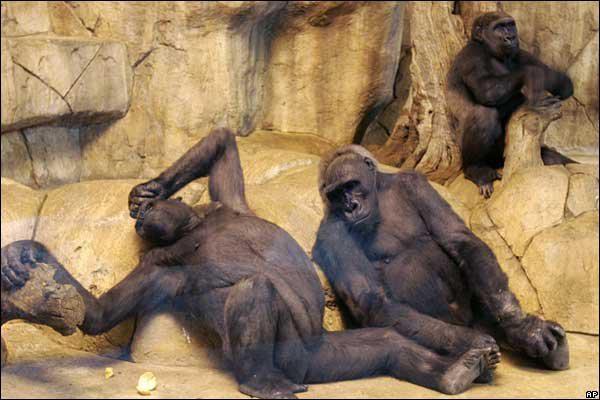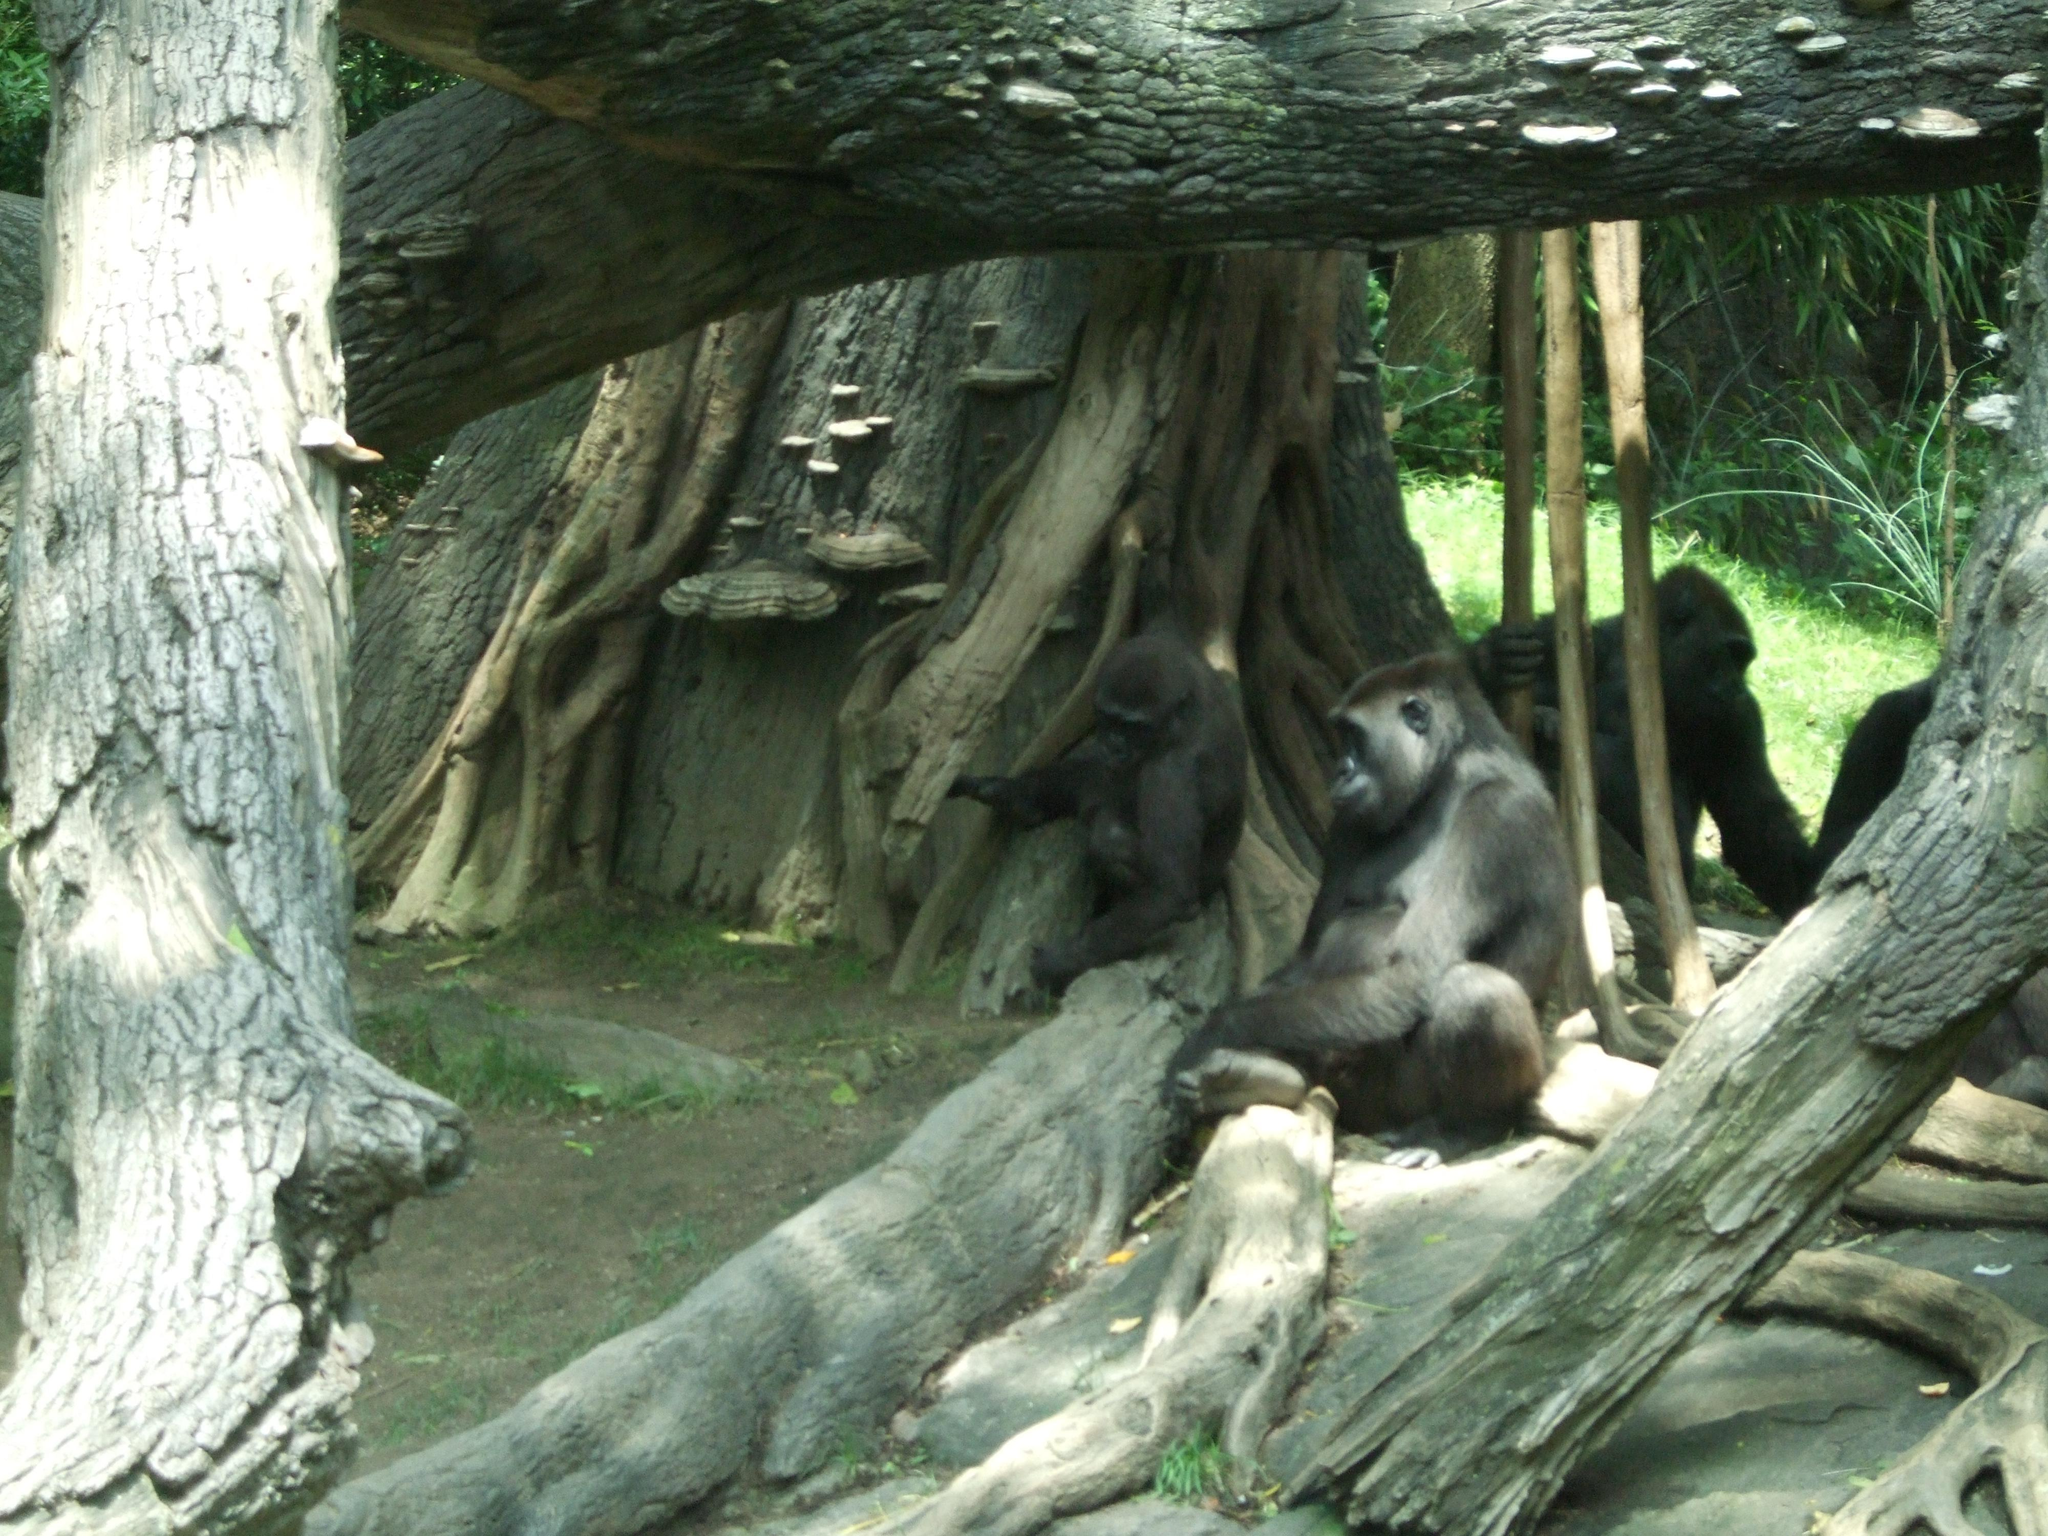The first image is the image on the left, the second image is the image on the right. Given the left and right images, does the statement "there are multiple gorillas sitting on logs in various sizes in front of a lasrge tree trunk" hold true? Answer yes or no. Yes. The first image is the image on the left, the second image is the image on the right. For the images displayed, is the sentence "One image shows multiple gorillas sitting on fallen logs in front of a massive tree trunk covered with twisted brown shapes." factually correct? Answer yes or no. Yes. 